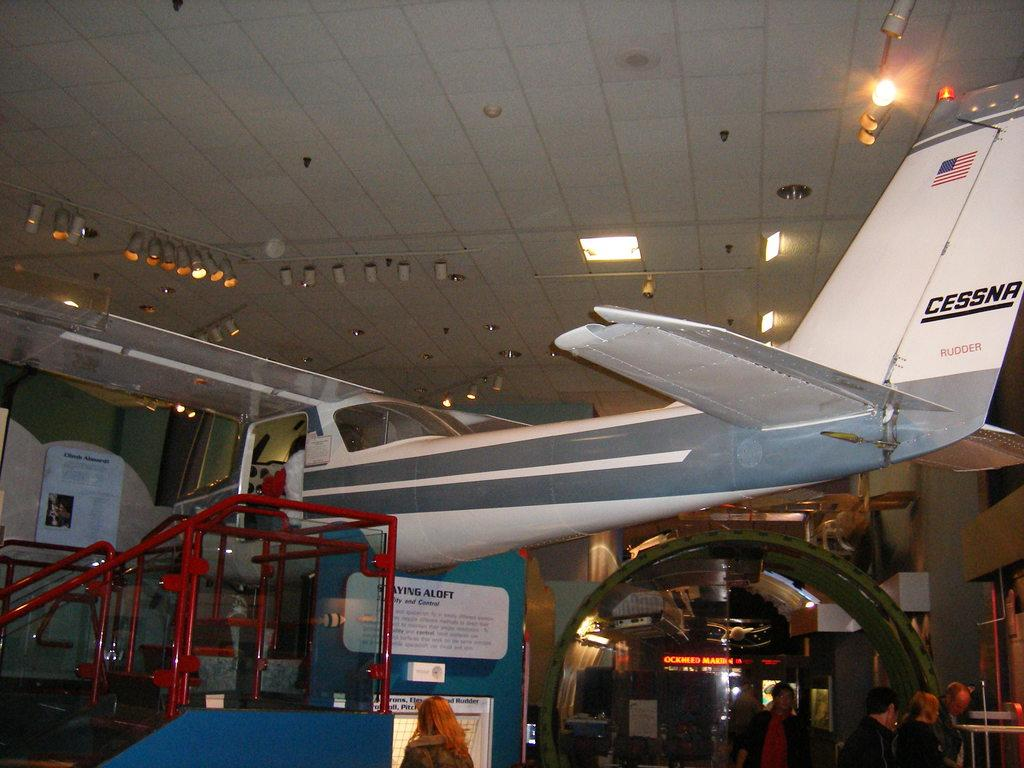<image>
Provide a brief description of the given image. A small Cessna aeroplane in a museum with people around it 